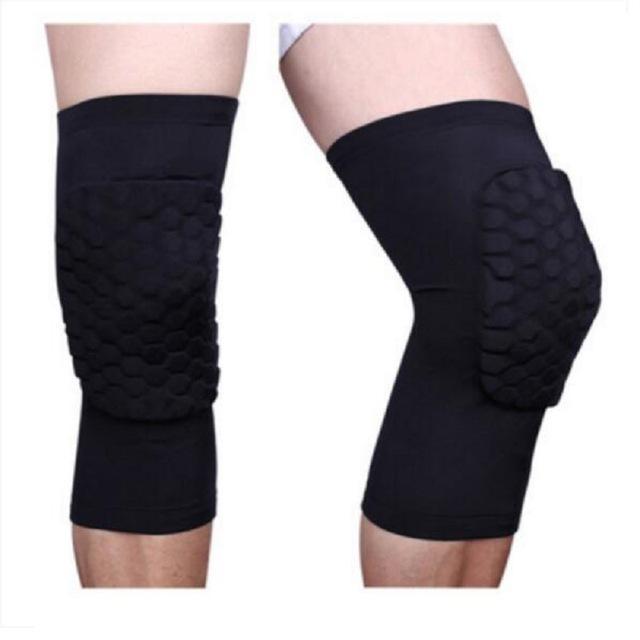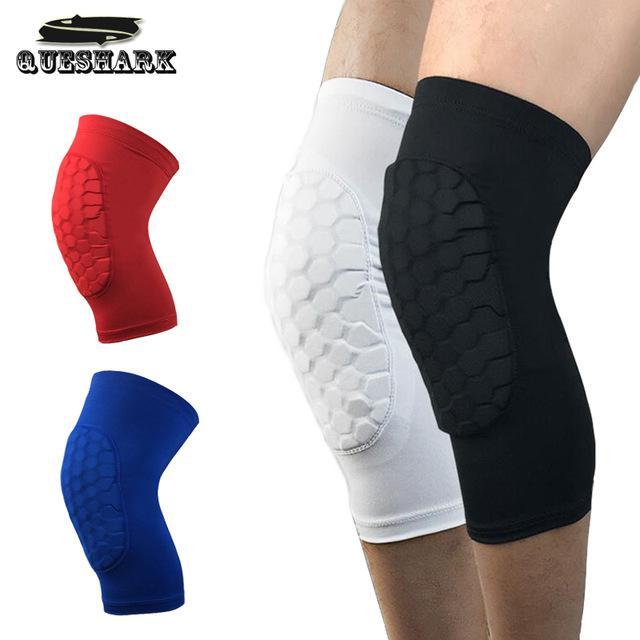The first image is the image on the left, the second image is the image on the right. For the images displayed, is the sentence "There are exactly seven knee pads in total." factually correct? Answer yes or no. No. The first image is the image on the left, the second image is the image on the right. Considering the images on both sides, is "There are exactly seven knee braces in total." valid? Answer yes or no. No. 